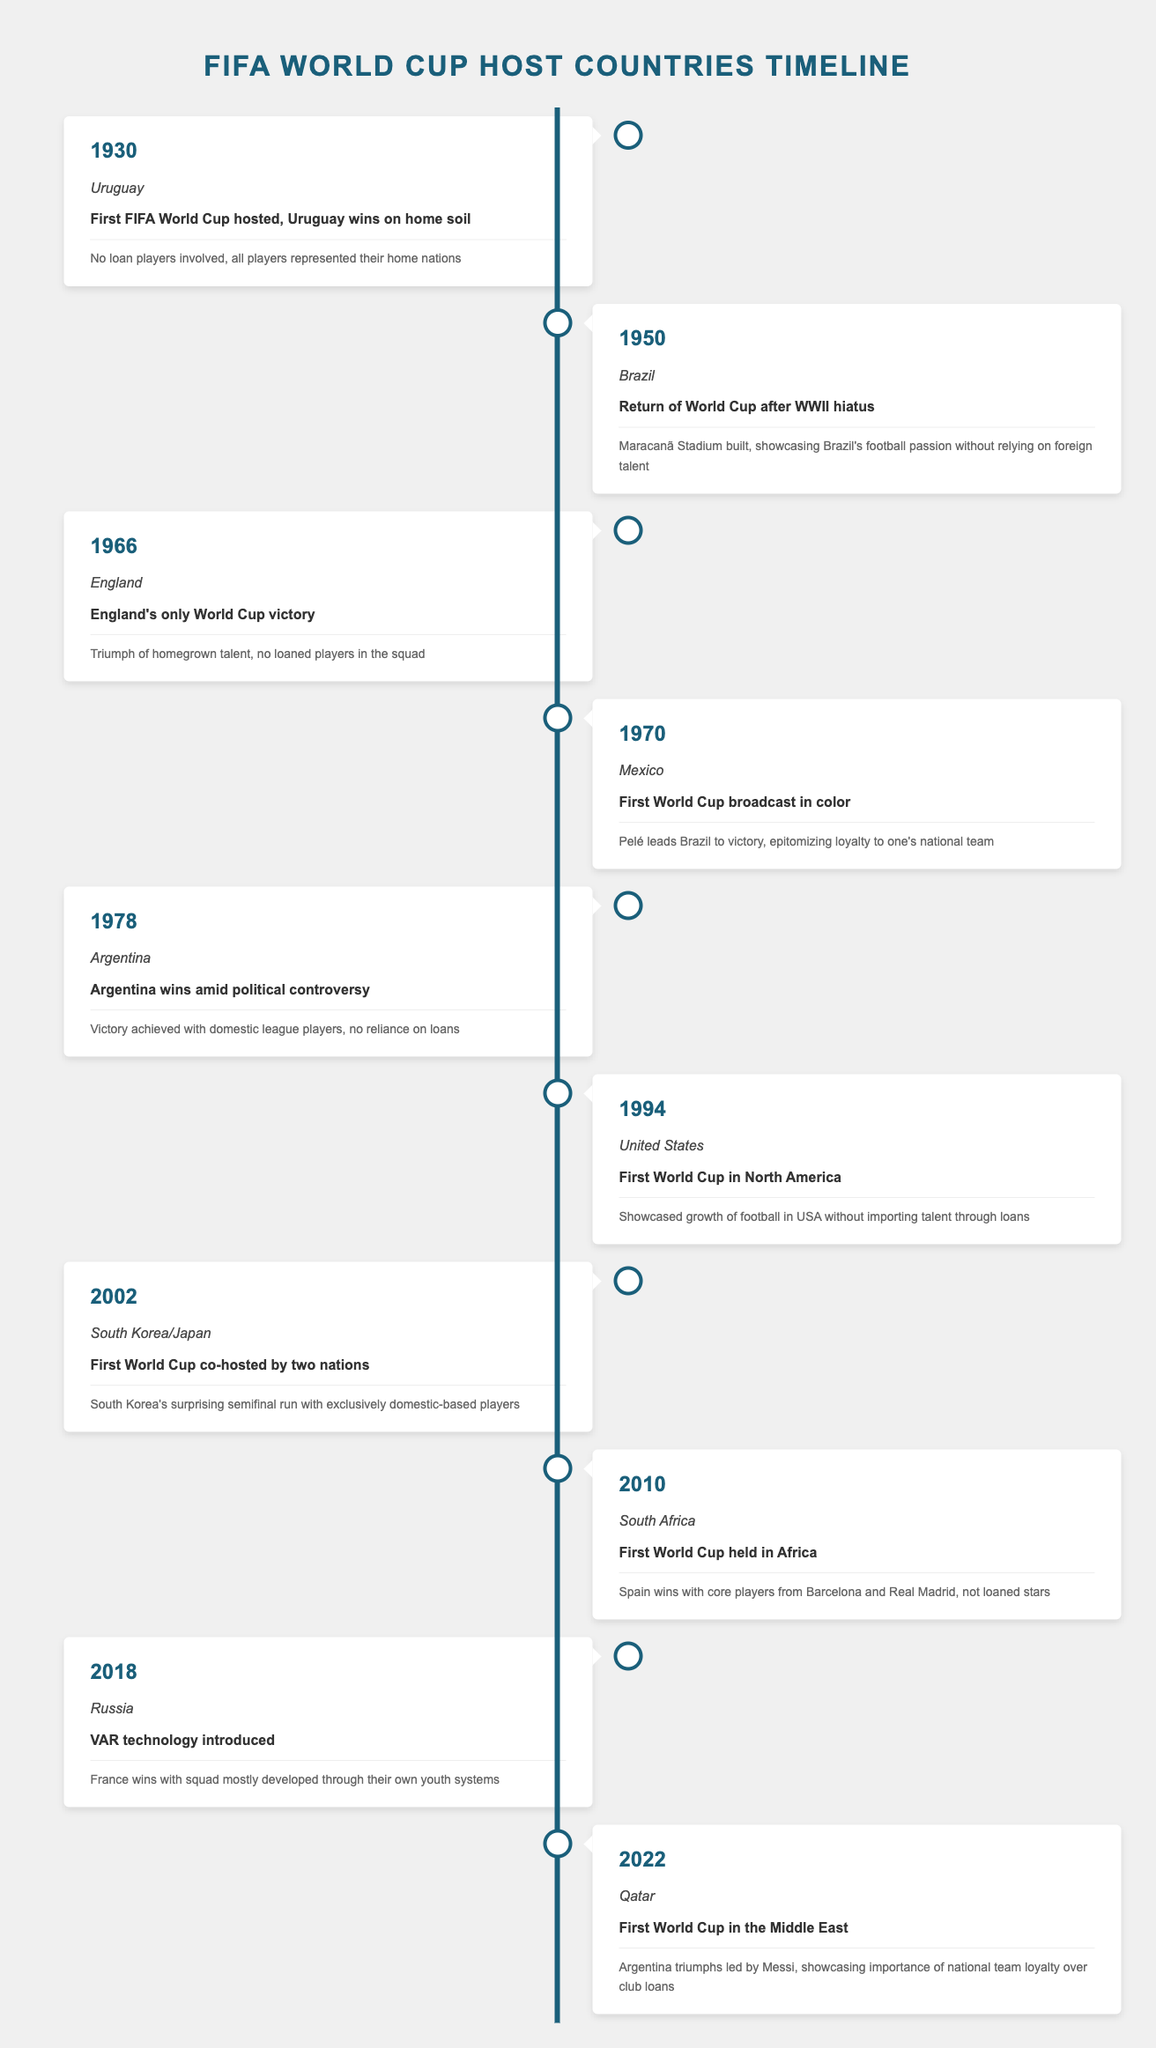What year did Uruguay host the first FIFA World Cup? The table states that Uruguay hosted the first FIFA World Cup in the year 1930.
Answer: 1930 Who won the World Cup in 1966? According to the table, England won their only World Cup in 1966.
Answer: England Was the 1994 World Cup held in Europe? The table indicates that the 1994 World Cup was held in the United States, which is in North America, not Europe.
Answer: No How many World Cups have been held in South America according to the table? By examining the host countries listed, the World Cups in South America are 1930 (Uruguay), 1950 (Brazil), and 1978 (Argentina), totaling three World Cups.
Answer: 3 Which World Cup was co-hosted by two nations? The table shows that the 2002 World Cup was co-hosted by South Korea and Japan.
Answer: 2002 What is the average year of the World Cups hosted between 1930 and 2018? The years of the World Cups hosted from the table are 1930, 1950, 1966, 1970, 1978, 1994, 2002, 2010, 2018. Adding these gives a total of 14,862 and dividing by 9 (the number of tournaments) gives an average year of approximately 1651.33.
Answer: 1651.33 Did any country win their hosting World Cup without loan players? The table notes that showcasing local talents, several countries, such as Uruguay in 1930 and England in 1966, won the tournament without loan players in their squad.
Answer: Yes Which event had the note that mentions a surprise semifinal run? Looking through the notes, the 2002 FIFA World Cup hosted by South Korea and Japan mentions South Korea's surprising semifinal run with exclusively domestic-based players.
Answer: 2002 How many host countries were in Europe? Referring to the table, the European host countries are England (1966), France (2018), and Russia (2018), totaling three host countries.
Answer: 3 